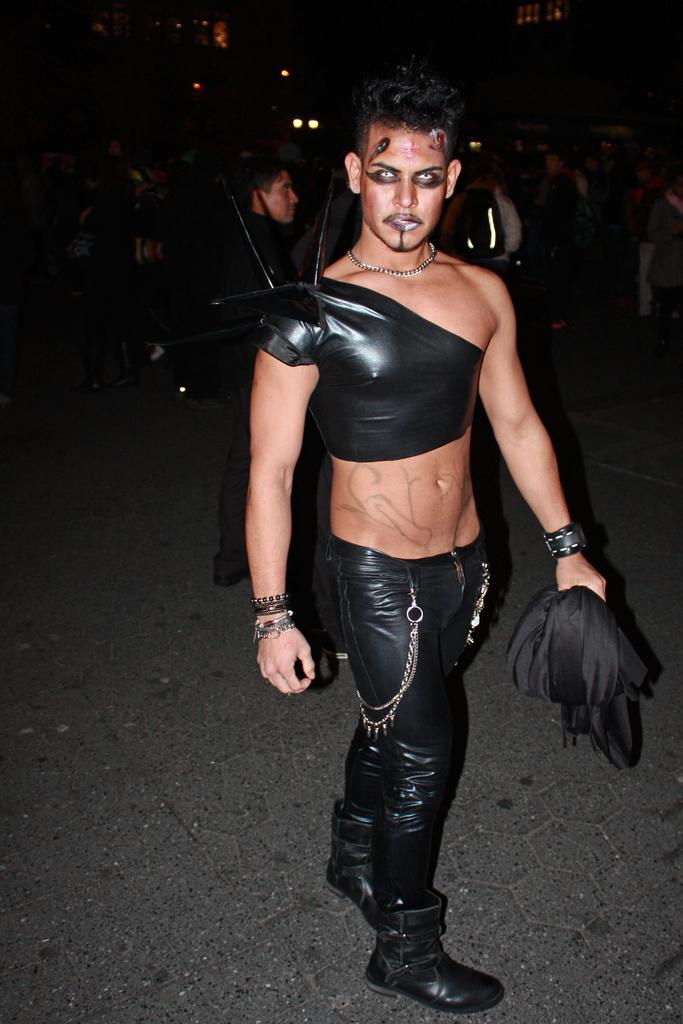Who is the main subject in the image? There is a man in the image. Where is the man positioned in the image? The man is positioned towards the right side of the image. What is the man wearing in the image? The man is wearing black clothes in the image. What is the man holding in his hand in the image? The man is holding a cloth in his hand in the image. Can you describe the background of the image? There are people in the background of the image. What type of spring is visible in the image? There is no spring present in the image. What kind of treatment is the man receiving in the image? The image does not depict any treatment being administered to the man. 